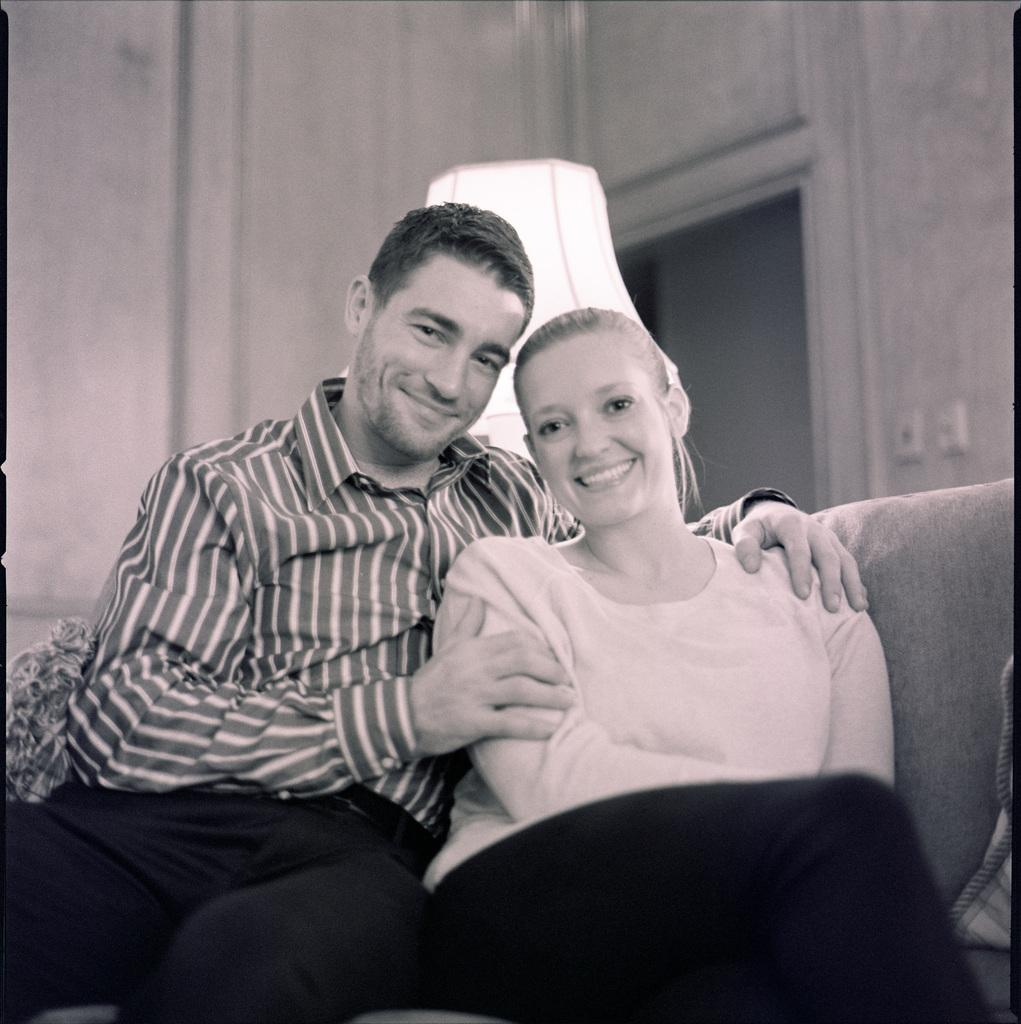What is the color scheme of the image? The image is black and white. Who can be seen in the image? There is a man and a woman in the image. What are the man and woman doing in the image? The man and woman are sitting on a couch and smiling. What can be seen in the background of the image? There is a lamp and a wall in the background of the image. What type of wine is the man holding in the image? There is no wine present in the image; it is a black and white image of a man and a woman sitting on a couch and smiling. 